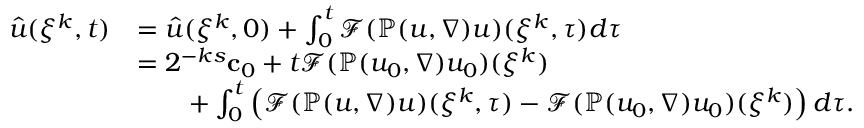<formula> <loc_0><loc_0><loc_500><loc_500>\begin{array} { r l } { \hat { u } ( \xi ^ { k } , t ) } & { = \hat { u } ( \xi ^ { k } , 0 ) + \int _ { 0 } ^ { t } \mathcal { F } ( \mathbb { P } ( u , \nabla ) u ) ( \xi ^ { k } , \tau ) d \tau } \\ & { = 2 ^ { - k s } { c } _ { 0 } + t \mathcal { F } ( \mathbb { P } ( u _ { 0 } , \nabla ) u _ { 0 } ) ( \xi ^ { k } ) } \\ & { \quad + \int _ { 0 } ^ { t } \left ( \mathcal { F } ( \mathbb { P } ( u , \nabla ) u ) ( \xi ^ { k } , \tau ) - \mathcal { F } ( \mathbb { P } ( u _ { 0 } , \nabla ) u _ { 0 } ) ( \xi ^ { k } ) \right ) d \tau . } \end{array}</formula> 